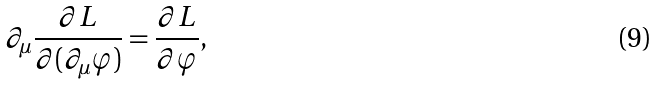Convert formula to latex. <formula><loc_0><loc_0><loc_500><loc_500>\partial _ { \mu } \frac { \partial L } { \partial ( \partial _ { \mu } \varphi ) } = \frac { \partial L } { \partial \varphi } ,</formula> 